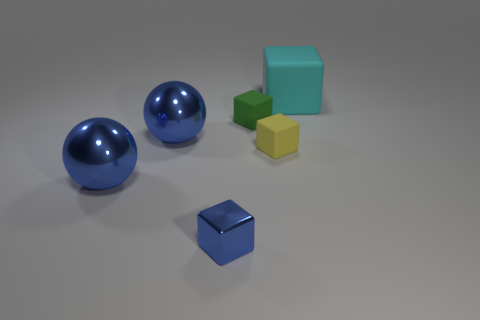Do the cyan block and the green cube have the same size?
Make the answer very short. No. What number of objects are small purple cylinders or rubber blocks?
Keep it short and to the point. 3. What shape is the large object that is right of the small object in front of the matte block in front of the small green object?
Your answer should be compact. Cube. Do the large object to the right of the tiny shiny block and the large blue ball that is in front of the tiny yellow matte cube have the same material?
Your answer should be compact. No. What material is the other large object that is the same shape as the green thing?
Offer a very short reply. Rubber. Is there any other thing that is the same size as the yellow thing?
Offer a very short reply. Yes. There is a large thing to the right of the tiny green matte block; is it the same shape as the tiny thing that is right of the tiny green matte block?
Provide a short and direct response. Yes. Are there fewer large matte blocks that are behind the tiny green matte block than rubber things that are in front of the metal cube?
Keep it short and to the point. No. What number of other objects are the same shape as the large cyan thing?
Ensure brevity in your answer.  3. There is a tiny yellow object that is made of the same material as the green object; what is its shape?
Offer a very short reply. Cube. 